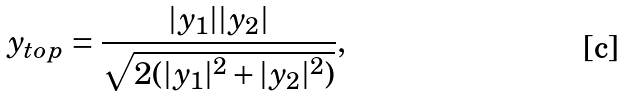<formula> <loc_0><loc_0><loc_500><loc_500>y _ { t o p } = \frac { | y _ { 1 } | | y _ { 2 } | } { \sqrt { 2 ( | y _ { 1 } | ^ { 2 } + | y _ { 2 } | ^ { 2 } ) } } ,</formula> 